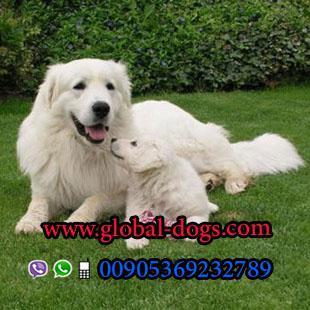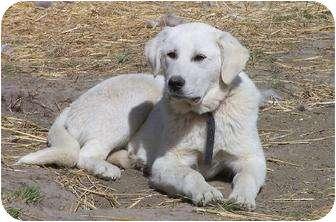The first image is the image on the left, the second image is the image on the right. Assess this claim about the two images: "An image includes a large white dog on the grass next to a sitting puppy with its nose raised to the adult dog's face.". Correct or not? Answer yes or no. Yes. The first image is the image on the left, the second image is the image on the right. Considering the images on both sides, is "The right image contains exactly one white dog." valid? Answer yes or no. Yes. 